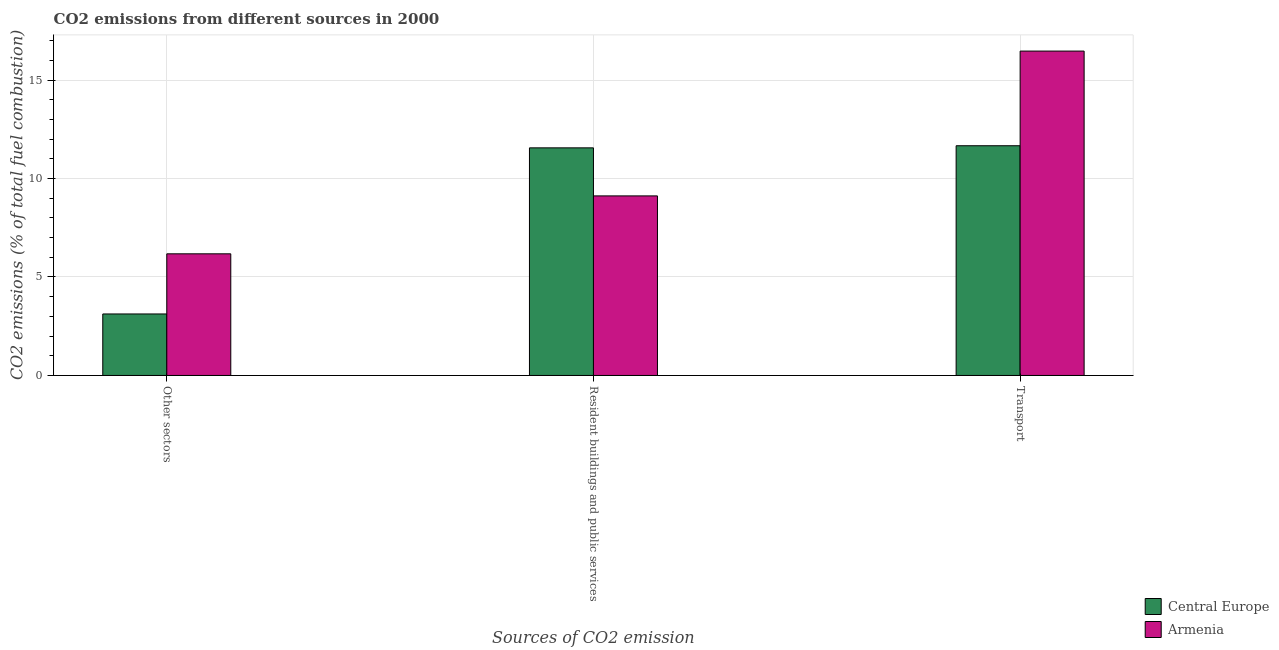Are the number of bars per tick equal to the number of legend labels?
Offer a very short reply. Yes. How many bars are there on the 3rd tick from the left?
Your response must be concise. 2. What is the label of the 1st group of bars from the left?
Your answer should be very brief. Other sectors. What is the percentage of co2 emissions from resident buildings and public services in Armenia?
Keep it short and to the point. 9.12. Across all countries, what is the maximum percentage of co2 emissions from resident buildings and public services?
Provide a succinct answer. 11.56. Across all countries, what is the minimum percentage of co2 emissions from transport?
Provide a short and direct response. 11.66. In which country was the percentage of co2 emissions from other sectors maximum?
Offer a terse response. Armenia. In which country was the percentage of co2 emissions from resident buildings and public services minimum?
Your answer should be very brief. Armenia. What is the total percentage of co2 emissions from transport in the graph?
Keep it short and to the point. 28.14. What is the difference between the percentage of co2 emissions from transport in Armenia and that in Central Europe?
Keep it short and to the point. 4.81. What is the difference between the percentage of co2 emissions from transport in Armenia and the percentage of co2 emissions from resident buildings and public services in Central Europe?
Give a very brief answer. 4.91. What is the average percentage of co2 emissions from transport per country?
Make the answer very short. 14.07. What is the difference between the percentage of co2 emissions from other sectors and percentage of co2 emissions from resident buildings and public services in Armenia?
Ensure brevity in your answer.  -2.94. What is the ratio of the percentage of co2 emissions from resident buildings and public services in Armenia to that in Central Europe?
Your answer should be very brief. 0.79. Is the difference between the percentage of co2 emissions from transport in Central Europe and Armenia greater than the difference between the percentage of co2 emissions from resident buildings and public services in Central Europe and Armenia?
Keep it short and to the point. No. What is the difference between the highest and the second highest percentage of co2 emissions from other sectors?
Make the answer very short. 3.05. What is the difference between the highest and the lowest percentage of co2 emissions from resident buildings and public services?
Your answer should be compact. 2.44. In how many countries, is the percentage of co2 emissions from resident buildings and public services greater than the average percentage of co2 emissions from resident buildings and public services taken over all countries?
Your answer should be compact. 1. What does the 2nd bar from the left in Resident buildings and public services represents?
Your answer should be very brief. Armenia. What does the 1st bar from the right in Transport represents?
Your answer should be compact. Armenia. Is it the case that in every country, the sum of the percentage of co2 emissions from other sectors and percentage of co2 emissions from resident buildings and public services is greater than the percentage of co2 emissions from transport?
Your answer should be compact. No. How many bars are there?
Keep it short and to the point. 6. Are all the bars in the graph horizontal?
Your response must be concise. No. How many countries are there in the graph?
Offer a very short reply. 2. What is the difference between two consecutive major ticks on the Y-axis?
Your answer should be compact. 5. Does the graph contain any zero values?
Offer a very short reply. No. Where does the legend appear in the graph?
Provide a succinct answer. Bottom right. How are the legend labels stacked?
Offer a terse response. Vertical. What is the title of the graph?
Your answer should be very brief. CO2 emissions from different sources in 2000. What is the label or title of the X-axis?
Ensure brevity in your answer.  Sources of CO2 emission. What is the label or title of the Y-axis?
Ensure brevity in your answer.  CO2 emissions (% of total fuel combustion). What is the CO2 emissions (% of total fuel combustion) of Central Europe in Other sectors?
Provide a short and direct response. 3.12. What is the CO2 emissions (% of total fuel combustion) in Armenia in Other sectors?
Keep it short and to the point. 6.18. What is the CO2 emissions (% of total fuel combustion) of Central Europe in Resident buildings and public services?
Your response must be concise. 11.56. What is the CO2 emissions (% of total fuel combustion) in Armenia in Resident buildings and public services?
Your answer should be compact. 9.12. What is the CO2 emissions (% of total fuel combustion) in Central Europe in Transport?
Offer a terse response. 11.66. What is the CO2 emissions (% of total fuel combustion) in Armenia in Transport?
Your answer should be very brief. 16.47. Across all Sources of CO2 emission, what is the maximum CO2 emissions (% of total fuel combustion) in Central Europe?
Give a very brief answer. 11.66. Across all Sources of CO2 emission, what is the maximum CO2 emissions (% of total fuel combustion) of Armenia?
Make the answer very short. 16.47. Across all Sources of CO2 emission, what is the minimum CO2 emissions (% of total fuel combustion) of Central Europe?
Your answer should be compact. 3.12. Across all Sources of CO2 emission, what is the minimum CO2 emissions (% of total fuel combustion) in Armenia?
Ensure brevity in your answer.  6.18. What is the total CO2 emissions (% of total fuel combustion) in Central Europe in the graph?
Keep it short and to the point. 26.34. What is the total CO2 emissions (% of total fuel combustion) of Armenia in the graph?
Ensure brevity in your answer.  31.76. What is the difference between the CO2 emissions (% of total fuel combustion) of Central Europe in Other sectors and that in Resident buildings and public services?
Make the answer very short. -8.43. What is the difference between the CO2 emissions (% of total fuel combustion) in Armenia in Other sectors and that in Resident buildings and public services?
Your answer should be compact. -2.94. What is the difference between the CO2 emissions (% of total fuel combustion) of Central Europe in Other sectors and that in Transport?
Ensure brevity in your answer.  -8.54. What is the difference between the CO2 emissions (% of total fuel combustion) in Armenia in Other sectors and that in Transport?
Provide a short and direct response. -10.29. What is the difference between the CO2 emissions (% of total fuel combustion) in Central Europe in Resident buildings and public services and that in Transport?
Offer a very short reply. -0.11. What is the difference between the CO2 emissions (% of total fuel combustion) in Armenia in Resident buildings and public services and that in Transport?
Your response must be concise. -7.35. What is the difference between the CO2 emissions (% of total fuel combustion) of Central Europe in Other sectors and the CO2 emissions (% of total fuel combustion) of Armenia in Resident buildings and public services?
Provide a short and direct response. -5.99. What is the difference between the CO2 emissions (% of total fuel combustion) of Central Europe in Other sectors and the CO2 emissions (% of total fuel combustion) of Armenia in Transport?
Give a very brief answer. -13.35. What is the difference between the CO2 emissions (% of total fuel combustion) of Central Europe in Resident buildings and public services and the CO2 emissions (% of total fuel combustion) of Armenia in Transport?
Your answer should be compact. -4.91. What is the average CO2 emissions (% of total fuel combustion) of Central Europe per Sources of CO2 emission?
Give a very brief answer. 8.78. What is the average CO2 emissions (% of total fuel combustion) in Armenia per Sources of CO2 emission?
Make the answer very short. 10.59. What is the difference between the CO2 emissions (% of total fuel combustion) of Central Europe and CO2 emissions (% of total fuel combustion) of Armenia in Other sectors?
Your answer should be very brief. -3.05. What is the difference between the CO2 emissions (% of total fuel combustion) of Central Europe and CO2 emissions (% of total fuel combustion) of Armenia in Resident buildings and public services?
Offer a very short reply. 2.44. What is the difference between the CO2 emissions (% of total fuel combustion) in Central Europe and CO2 emissions (% of total fuel combustion) in Armenia in Transport?
Ensure brevity in your answer.  -4.81. What is the ratio of the CO2 emissions (% of total fuel combustion) of Central Europe in Other sectors to that in Resident buildings and public services?
Ensure brevity in your answer.  0.27. What is the ratio of the CO2 emissions (% of total fuel combustion) in Armenia in Other sectors to that in Resident buildings and public services?
Provide a short and direct response. 0.68. What is the ratio of the CO2 emissions (% of total fuel combustion) of Central Europe in Other sectors to that in Transport?
Ensure brevity in your answer.  0.27. What is the ratio of the CO2 emissions (% of total fuel combustion) in Central Europe in Resident buildings and public services to that in Transport?
Ensure brevity in your answer.  0.99. What is the ratio of the CO2 emissions (% of total fuel combustion) in Armenia in Resident buildings and public services to that in Transport?
Provide a short and direct response. 0.55. What is the difference between the highest and the second highest CO2 emissions (% of total fuel combustion) of Central Europe?
Your answer should be compact. 0.11. What is the difference between the highest and the second highest CO2 emissions (% of total fuel combustion) of Armenia?
Offer a very short reply. 7.35. What is the difference between the highest and the lowest CO2 emissions (% of total fuel combustion) in Central Europe?
Your answer should be compact. 8.54. What is the difference between the highest and the lowest CO2 emissions (% of total fuel combustion) in Armenia?
Offer a terse response. 10.29. 